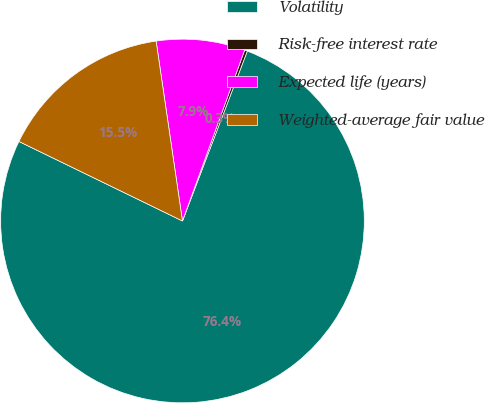Convert chart to OTSL. <chart><loc_0><loc_0><loc_500><loc_500><pie_chart><fcel>Volatility<fcel>Risk-free interest rate<fcel>Expected life (years)<fcel>Weighted-average fair value<nl><fcel>76.39%<fcel>0.25%<fcel>7.87%<fcel>15.48%<nl></chart> 